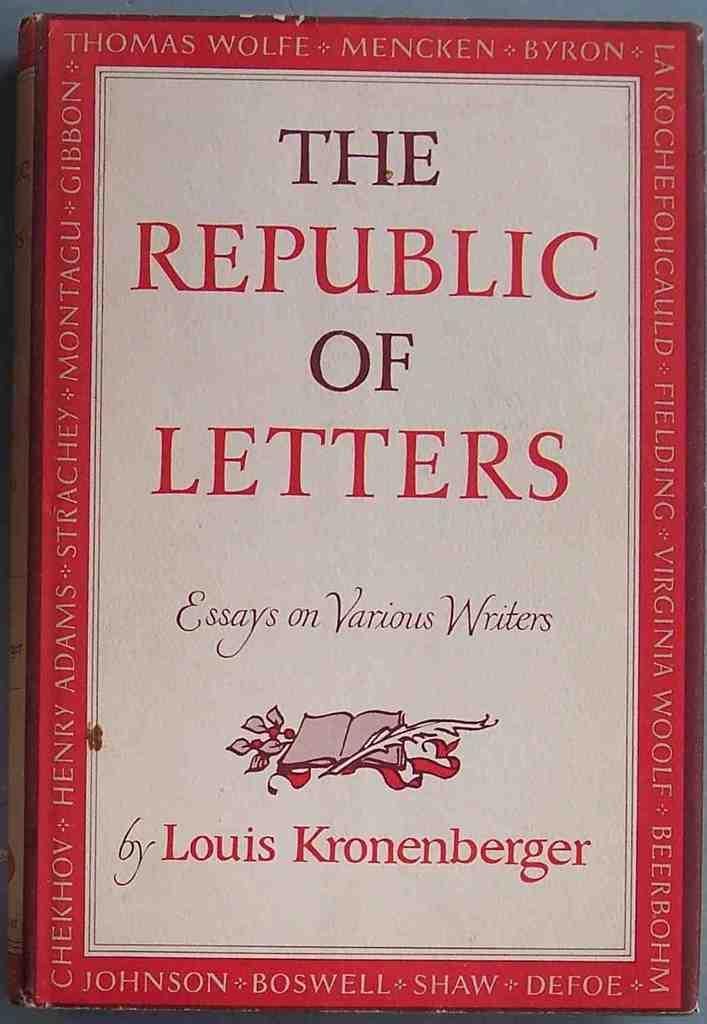Who is the author of the book?
Your answer should be very brief. Louis kronenberger. 